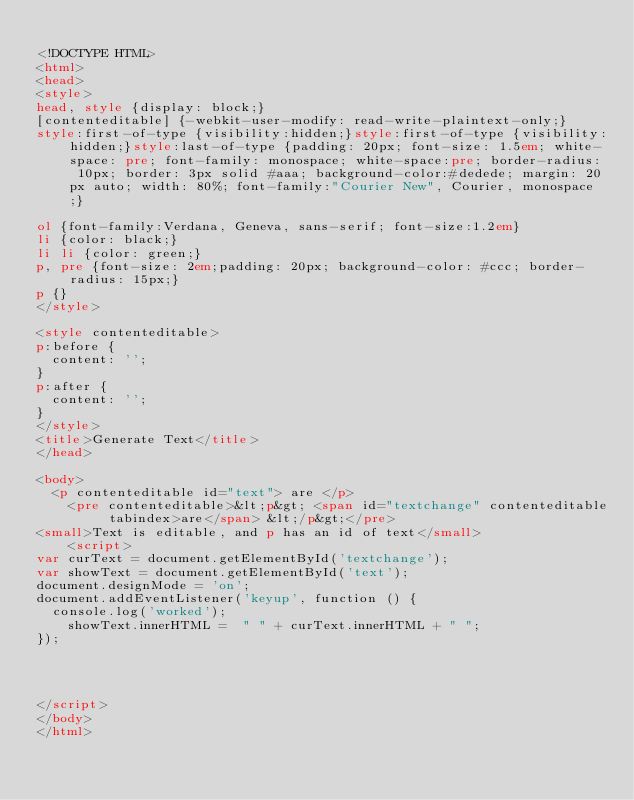Convert code to text. <code><loc_0><loc_0><loc_500><loc_500><_HTML_>
<!DOCTYPE HTML>
<html>
<head>
<style>
head, style {display: block;}
[contenteditable] {-webkit-user-modify: read-write-plaintext-only;}
style:first-of-type {visibility:hidden;}style:first-of-type {visibility:hidden;}style:last-of-type {padding: 20px; font-size: 1.5em; white-space: pre; font-family: monospace; white-space:pre; border-radius: 10px; border: 3px solid #aaa; background-color:#dedede; margin: 20px auto; width: 80%; font-family:"Courier New", Courier, monospace;}

ol {font-family:Verdana, Geneva, sans-serif; font-size:1.2em}
li {color: black;}
li li {color: green;}
p, pre {font-size: 2em;padding: 20px; background-color: #ccc; border-radius: 15px;}
p {}
</style>

<style contenteditable>
p:before {
	content: '';
}
p:after {
	content: '';
}
</style>
<title>Generate Text</title>
</head>

<body>
	<p contenteditable id="text"> are </p>
    <pre contenteditable>&lt;p&gt; <span id="textchange" contenteditable tabindex>are</span> &lt;/p&gt;</pre>
<small>Text is editable, and p has an id of text</small>
    <script>
var curText = document.getElementById('textchange');
var showText = document.getElementById('text');
document.designMode = 'on';
document.addEventListener('keyup', function () {
	console.log('worked');
  	showText.innerHTML =  " " + curText.innerHTML + " ";
});




</script>
</body>
</html>

</code> 